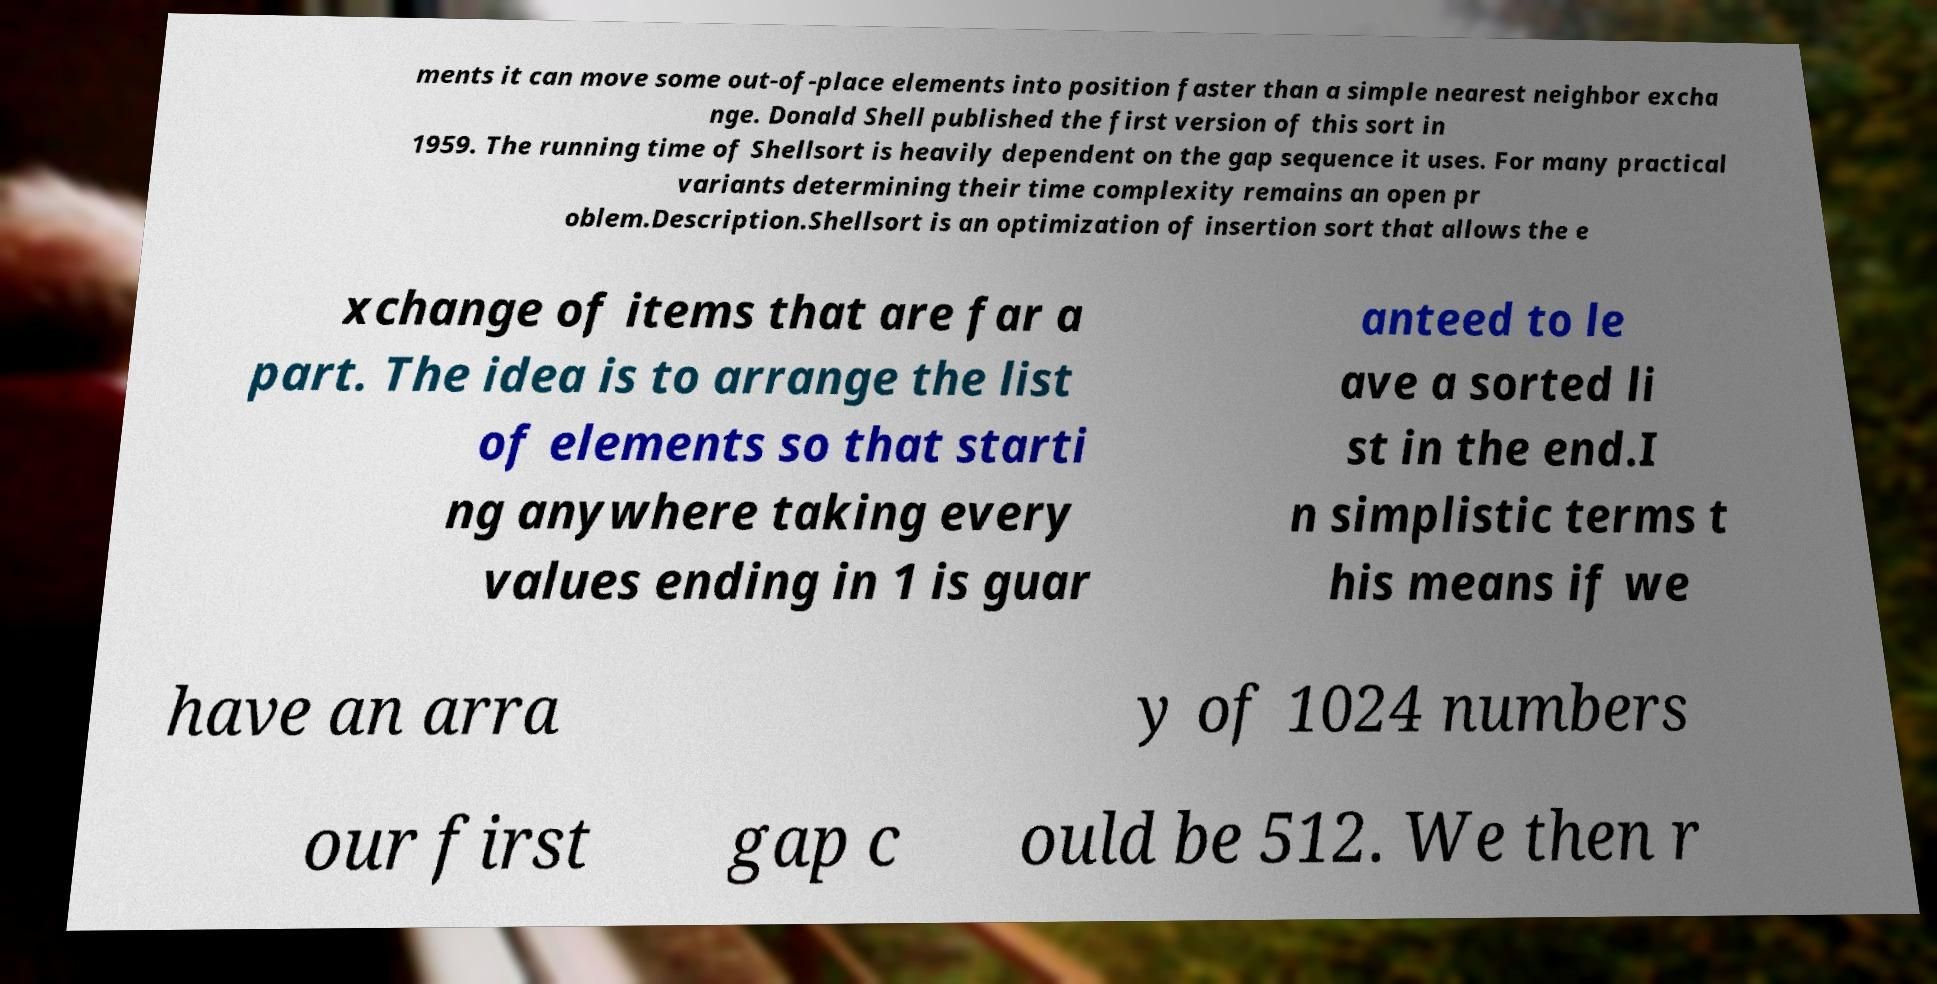There's text embedded in this image that I need extracted. Can you transcribe it verbatim? ments it can move some out-of-place elements into position faster than a simple nearest neighbor excha nge. Donald Shell published the first version of this sort in 1959. The running time of Shellsort is heavily dependent on the gap sequence it uses. For many practical variants determining their time complexity remains an open pr oblem.Description.Shellsort is an optimization of insertion sort that allows the e xchange of items that are far a part. The idea is to arrange the list of elements so that starti ng anywhere taking every values ending in 1 is guar anteed to le ave a sorted li st in the end.I n simplistic terms t his means if we have an arra y of 1024 numbers our first gap c ould be 512. We then r 